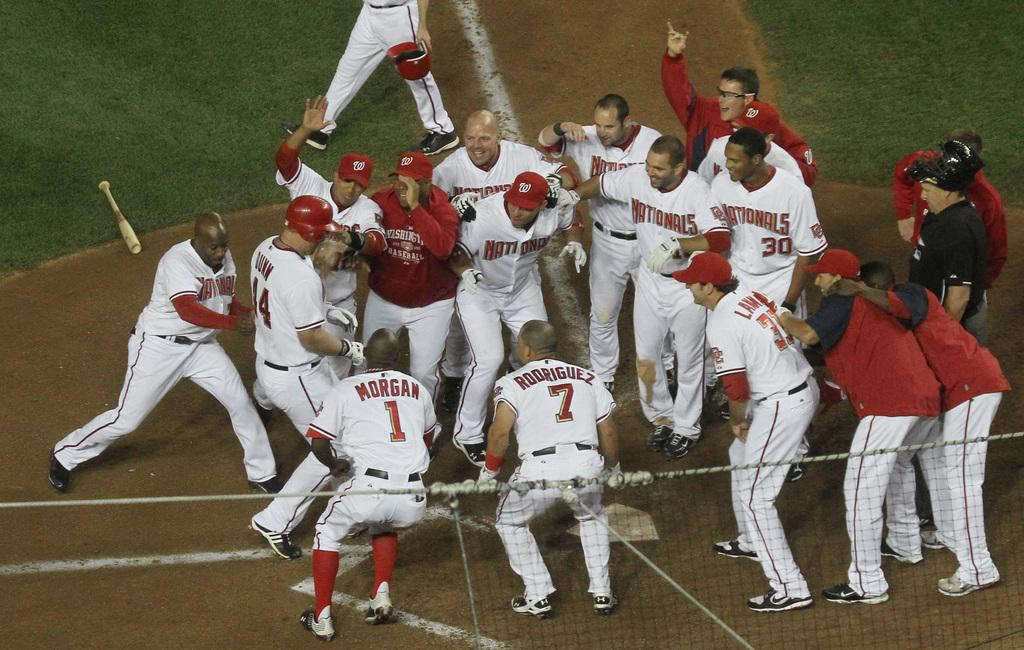<image>
Provide a brief description of the given image. a group of Nationals players where one has the name Morgan on the back 